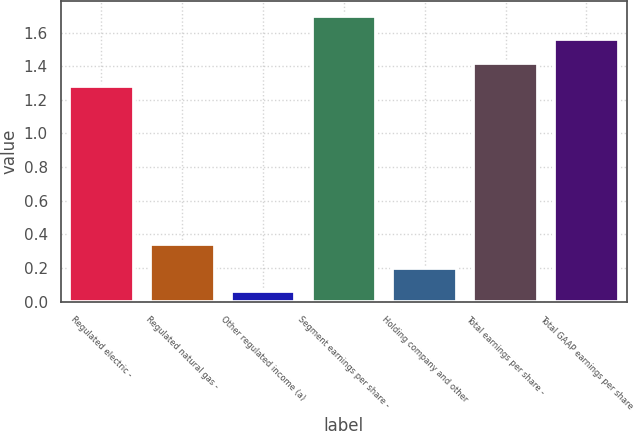<chart> <loc_0><loc_0><loc_500><loc_500><bar_chart><fcel>Regulated electric -<fcel>Regulated natural gas -<fcel>Other regulated income (a)<fcel>Segment earnings per share -<fcel>Holding company and other<fcel>Total earnings per share -<fcel>Total GAAP earnings per share<nl><fcel>1.28<fcel>0.34<fcel>0.06<fcel>1.7<fcel>0.2<fcel>1.42<fcel>1.56<nl></chart> 